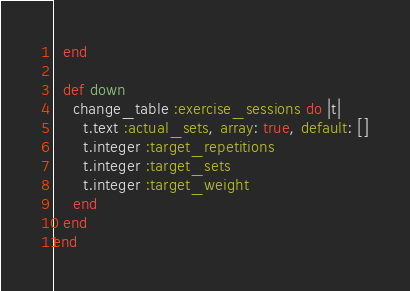<code> <loc_0><loc_0><loc_500><loc_500><_Ruby_>  end

  def down
    change_table :exercise_sessions do |t|
      t.text :actual_sets, array: true, default: []
      t.integer :target_repetitions
      t.integer :target_sets
      t.integer :target_weight
    end
  end
end
</code> 